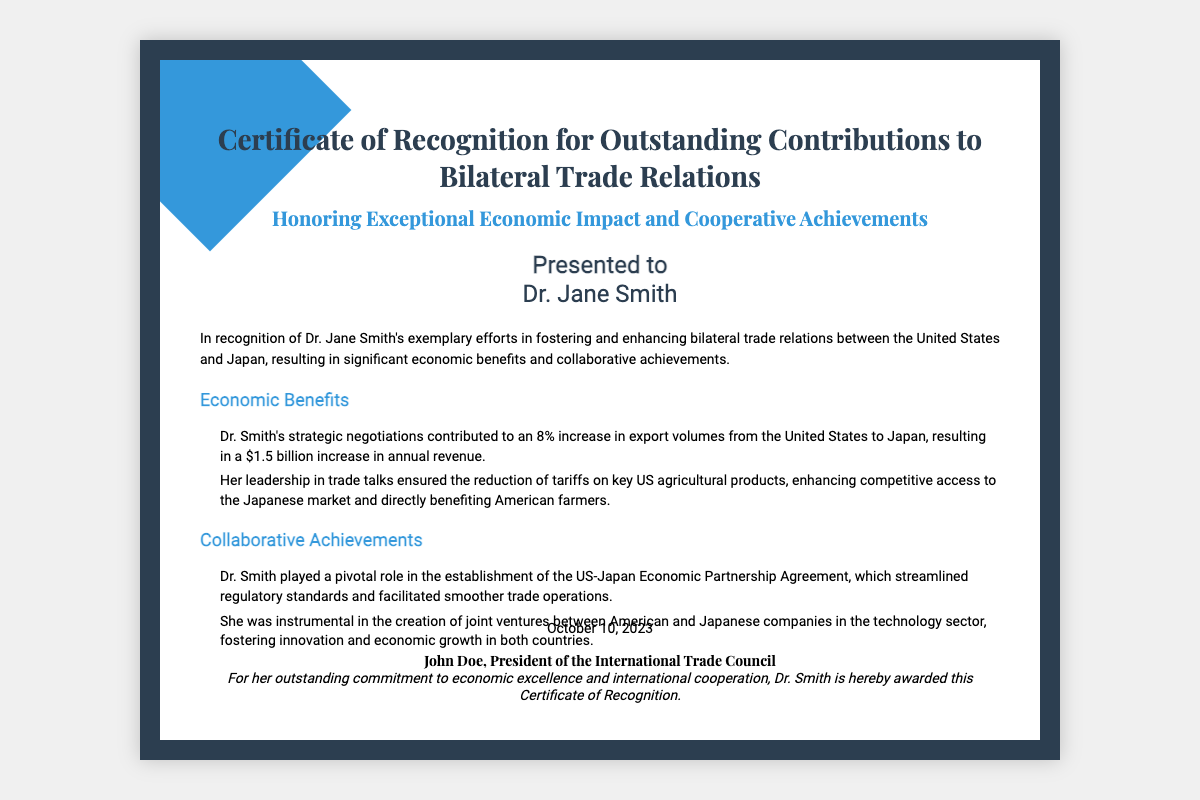What is the certificate title? The title of the certificate is explicitly mentioned at the top of the document.
Answer: Certificate of Recognition for Outstanding Contributions to Bilateral Trade Relations Who is the recipient of the certificate? The document states the name of the individual being honored with the certificate.
Answer: Dr. Jane Smith What percentage increase in export volumes is attributed to Dr. Smith's negotiations? The document provides a specific percentage increase related to export volumes as a result of Dr. Smith's contributions.
Answer: 8% What was the increase in annual revenue from the increase in export volumes? The document states the financial impact of the export volume increase.
Answer: $1.5 billion What agreement did Dr. Smith help establish? The document mentions a specific agreement that Dr. Smith played a key role in creating.
Answer: US-Japan Economic Partnership Agreement What type of products had tariffs reduced? The document specifies the category of products that benefited from reduced tariffs due to Dr. Smith's efforts.
Answer: Agricultural products What is the date on which the certificate was awarded? The document includes the specific date of recognition at the bottom of the certificate.
Answer: October 10, 2023 Who signed the certificate? The document identifies the individual who authorized the recognition with a signature at the bottom.
Answer: John Doe What council is John Doe president of? The document clearly states the title of John Doe in relation to an organization mentioned at the bottom.
Answer: International Trade Council 